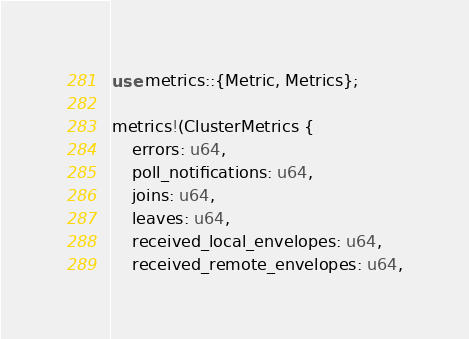<code> <loc_0><loc_0><loc_500><loc_500><_Rust_>use metrics::{Metric, Metrics};

metrics!(ClusterMetrics {
    errors: u64,
    poll_notifications: u64,
    joins: u64,
    leaves: u64,
    received_local_envelopes: u64,
    received_remote_envelopes: u64,</code> 